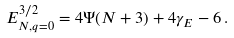<formula> <loc_0><loc_0><loc_500><loc_500>E ^ { 3 / 2 } _ { N , q = 0 } = 4 \Psi ( N + 3 ) + 4 \gamma _ { E } - 6 \, .</formula> 